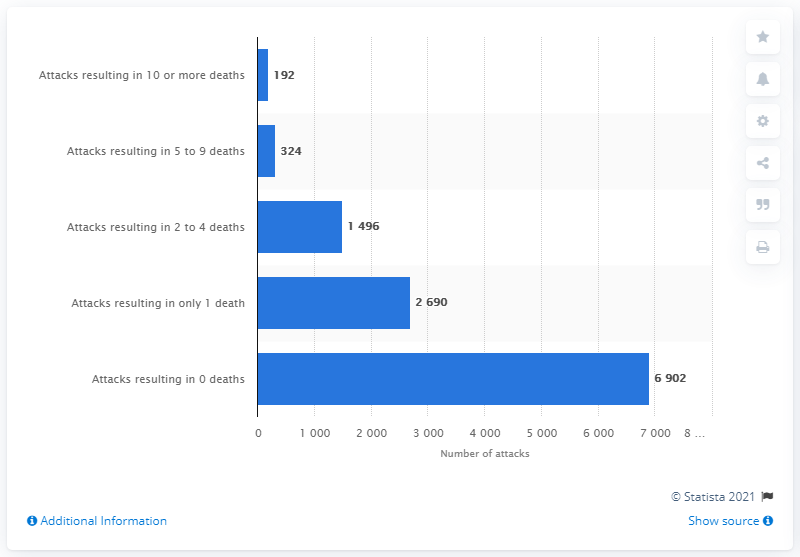Outline some significant characteristics in this image. In 2010, there were 516 terrorist attacks that resulted in at least 5 deaths or more. There were 2690 reported incidents of terrorism in 2010 that resulted in at least one death. In 2010, there were 192 terrorist attacks that resulted in 10 or more deaths. 